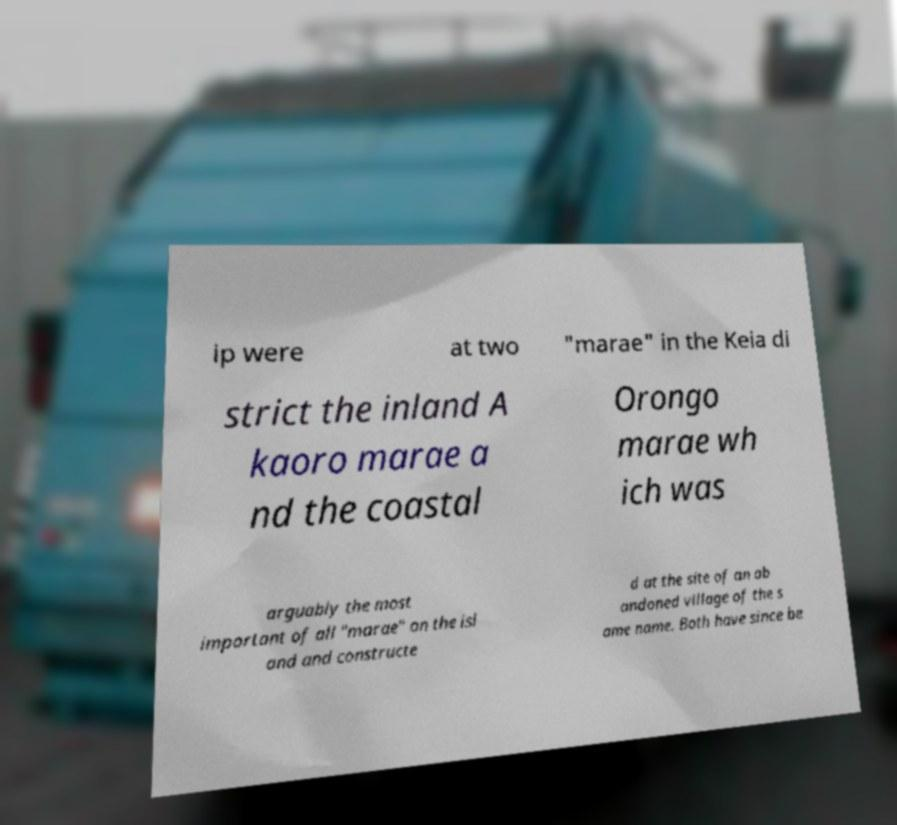Could you extract and type out the text from this image? ip were at two "marae" in the Keia di strict the inland A kaoro marae a nd the coastal Orongo marae wh ich was arguably the most important of all "marae" on the isl and and constructe d at the site of an ab andoned village of the s ame name. Both have since be 